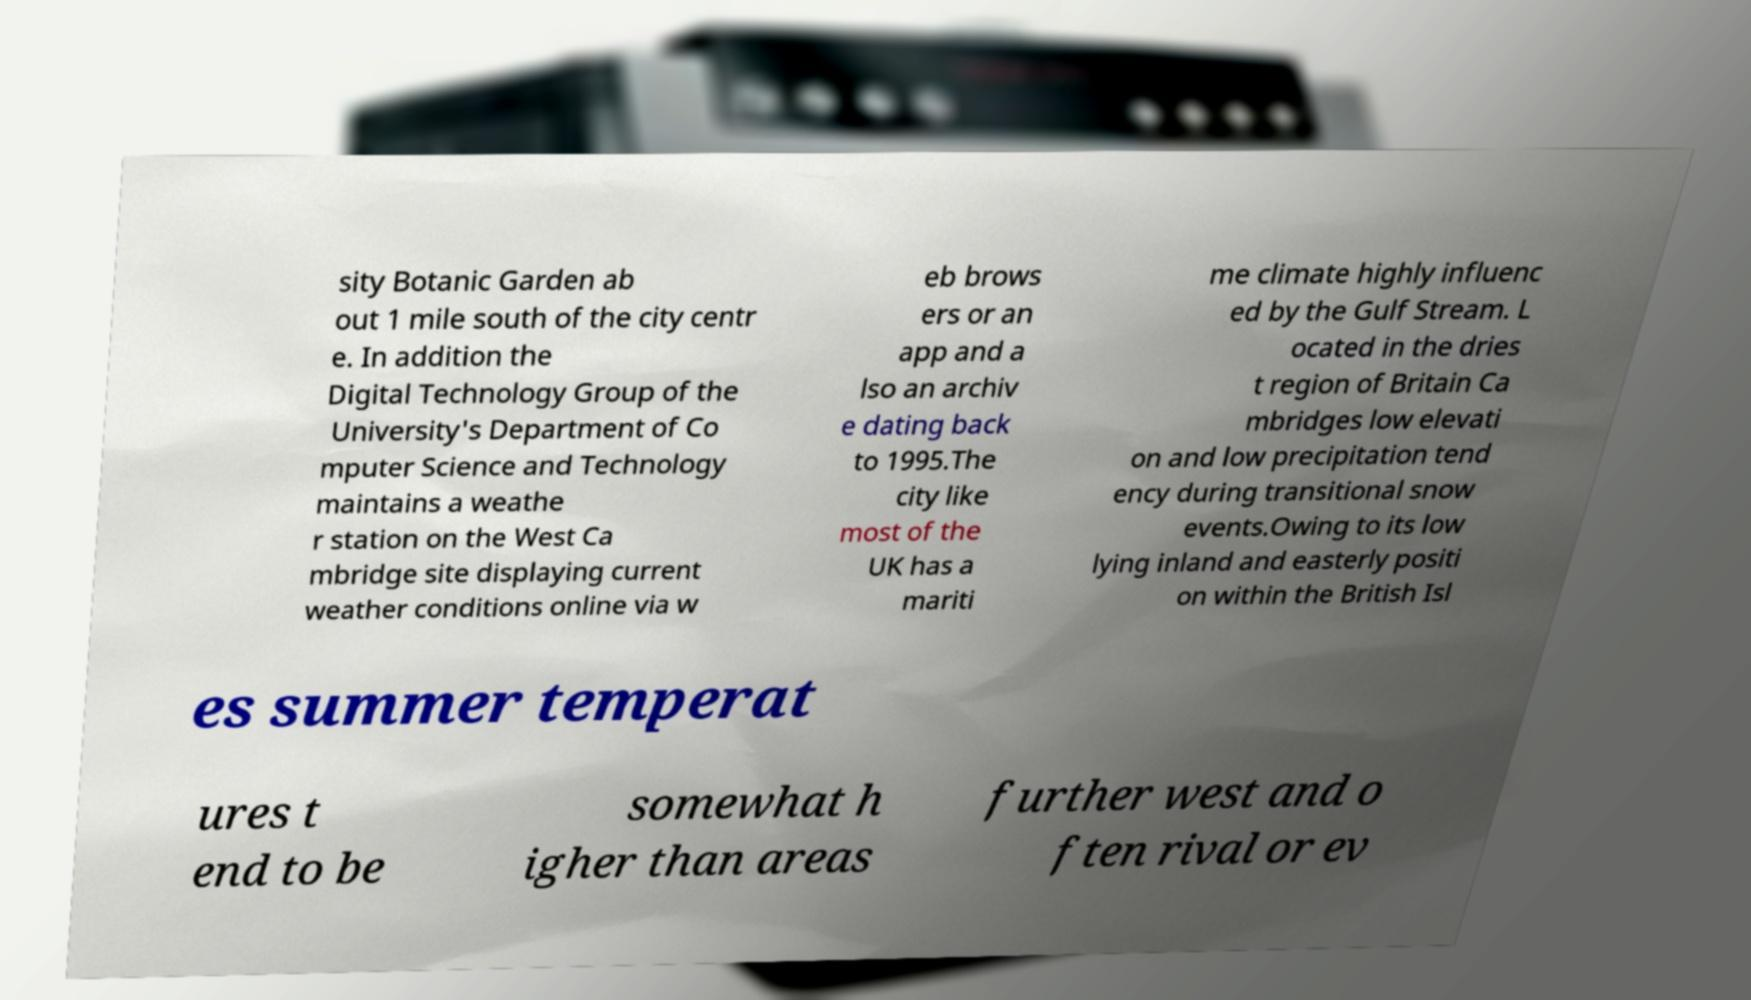Could you extract and type out the text from this image? sity Botanic Garden ab out 1 mile south of the city centr e. In addition the Digital Technology Group of the University's Department of Co mputer Science and Technology maintains a weathe r station on the West Ca mbridge site displaying current weather conditions online via w eb brows ers or an app and a lso an archiv e dating back to 1995.The city like most of the UK has a mariti me climate highly influenc ed by the Gulf Stream. L ocated in the dries t region of Britain Ca mbridges low elevati on and low precipitation tend ency during transitional snow events.Owing to its low lying inland and easterly positi on within the British Isl es summer temperat ures t end to be somewhat h igher than areas further west and o ften rival or ev 